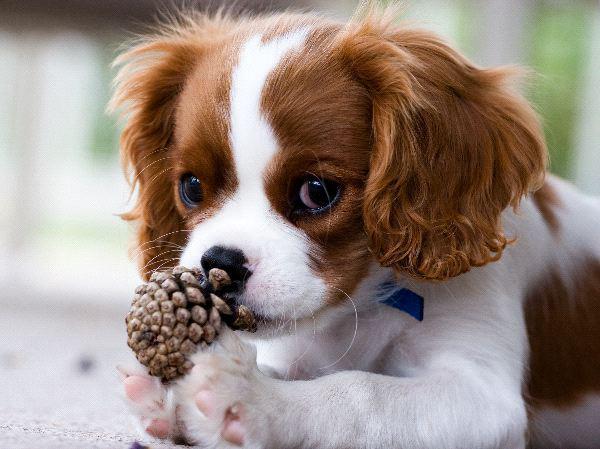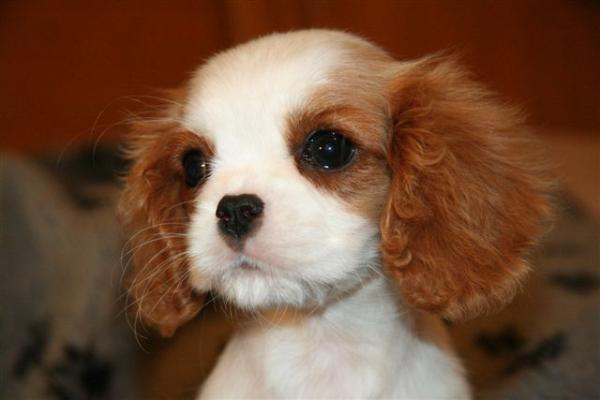The first image is the image on the left, the second image is the image on the right. Given the left and right images, does the statement "One of the images shows an inanimate object with the dog." hold true? Answer yes or no. Yes. 